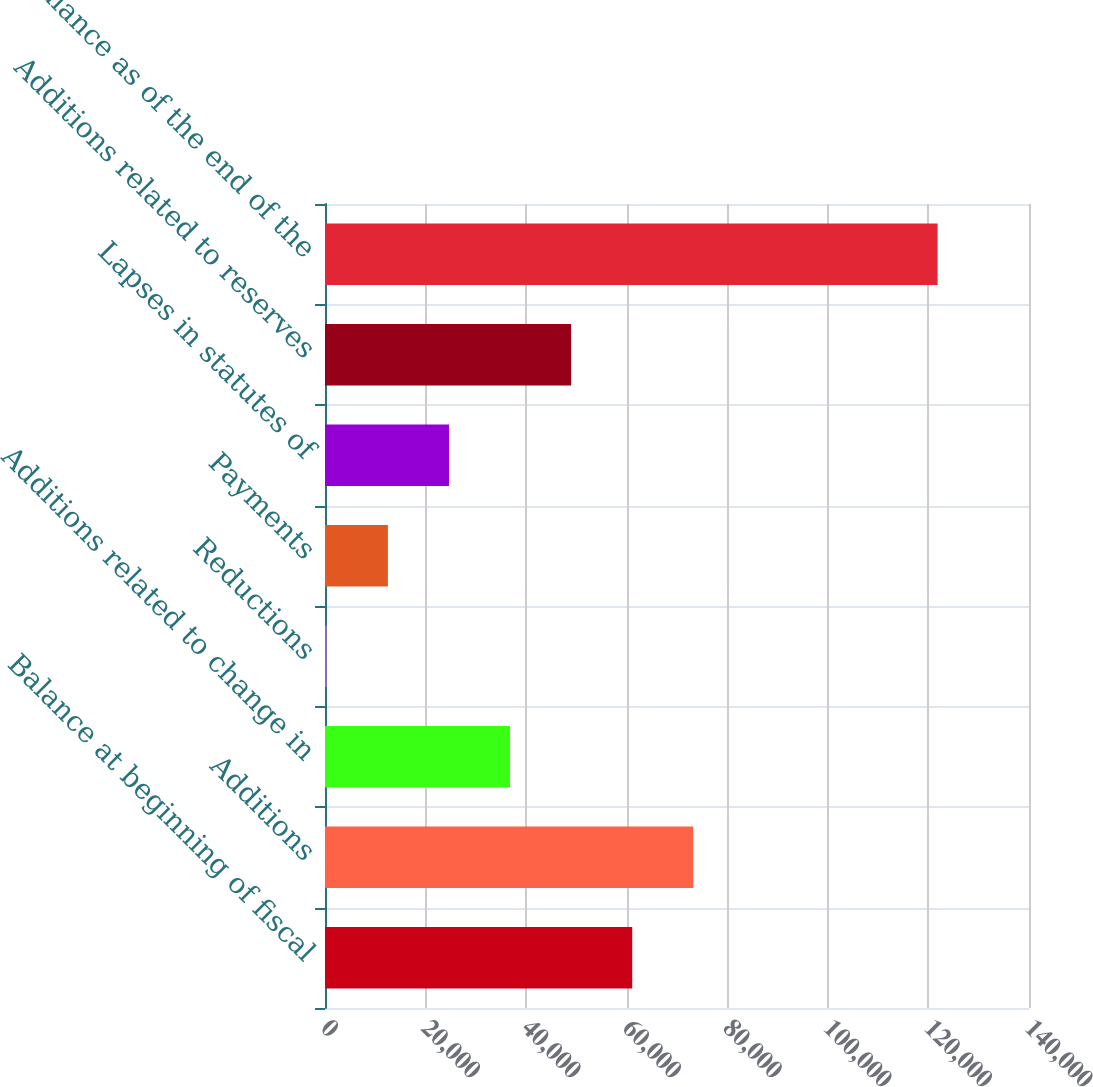Convert chart to OTSL. <chart><loc_0><loc_0><loc_500><loc_500><bar_chart><fcel>Balance at beginning of fiscal<fcel>Additions<fcel>Additions related to change in<fcel>Reductions<fcel>Payments<fcel>Lapses in statutes of<fcel>Additions related to reserves<fcel>Balance as of the end of the<nl><fcel>61094.5<fcel>73240.8<fcel>36801.9<fcel>363<fcel>12509.3<fcel>24655.6<fcel>48948.2<fcel>121826<nl></chart> 